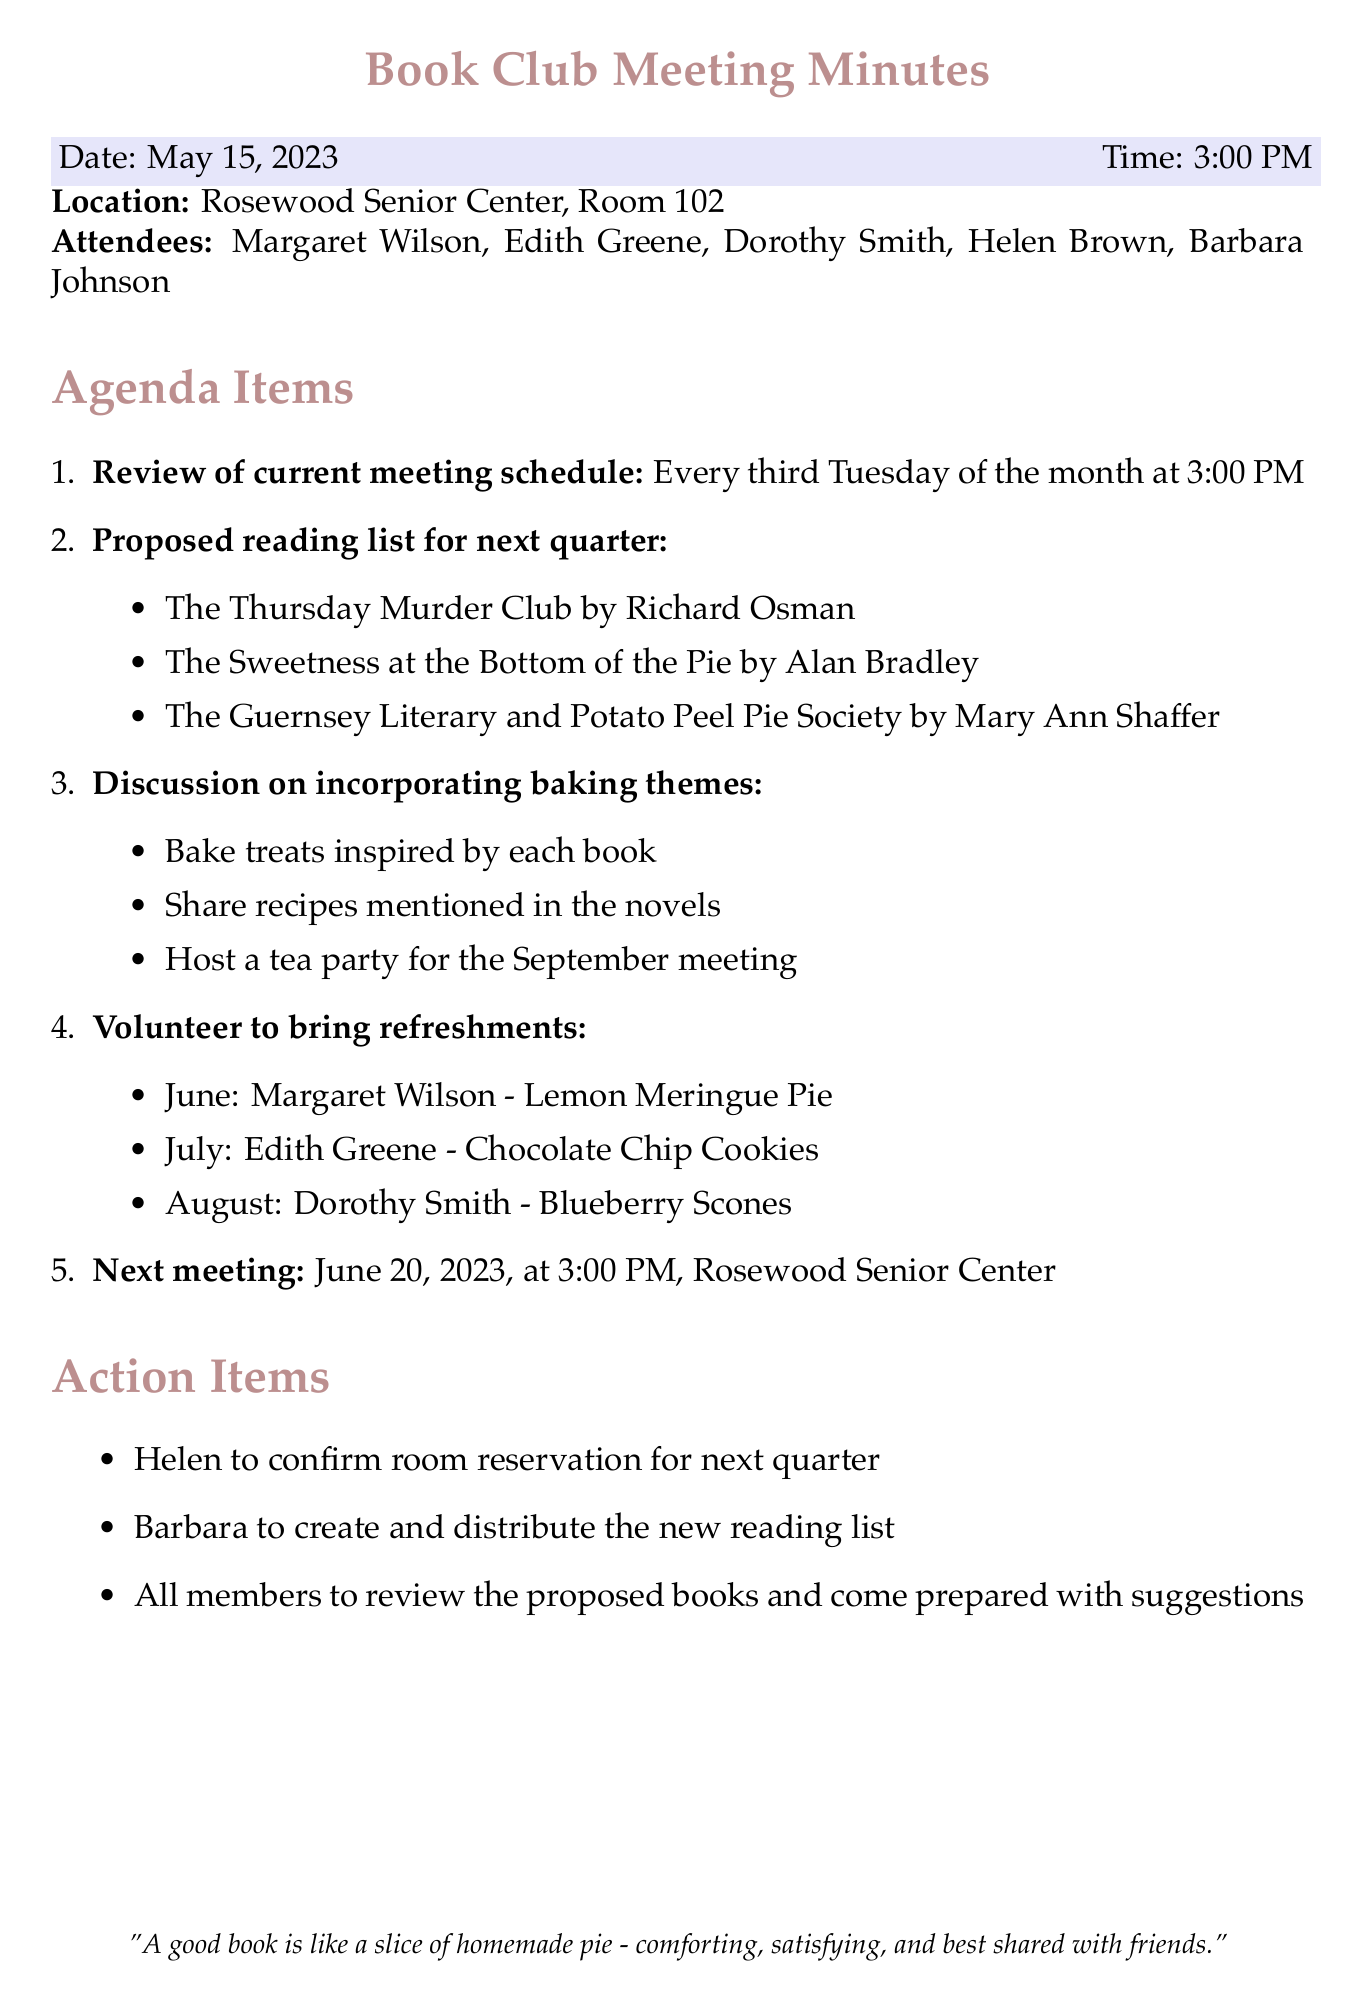What is the date of the meeting? The date of the meeting is mentioned in the document as May 15, 2023.
Answer: May 15, 2023 Who will bring refreshments in June? The document states that Margaret Wilson will bring Lemon Meringue Pie in June.
Answer: Margaret Wilson What is the location of the meeting? The meeting is scheduled to be held at the Rosewood Senior Center, Room 102.
Answer: Rosewood Senior Center, Room 102 How many books are listed in the proposed reading list? The document lists three books for the next quarter reading list.
Answer: Three What is the theme suggested for the September meeting? The proposal includes hosting a tea party for the September meeting as part of the baking theme discussion.
Answer: Tea party Who is responsible for confirming the room reservation? According to the action items in the document, Helen is tasked with confirming the room reservation for the next quarter.
Answer: Helen What time do the book club meetings occur? The document specifies that the book club meetings occur at 3:00 PM.
Answer: 3:00 PM Which book is written by Richard Osman? The proposed reading list includes "The Thursday Murder Club" by Richard Osman.
Answer: The Thursday Murder Club What is the next meeting date? The document states that the next meeting is scheduled for June 20, 2023.
Answer: June 20, 2023 